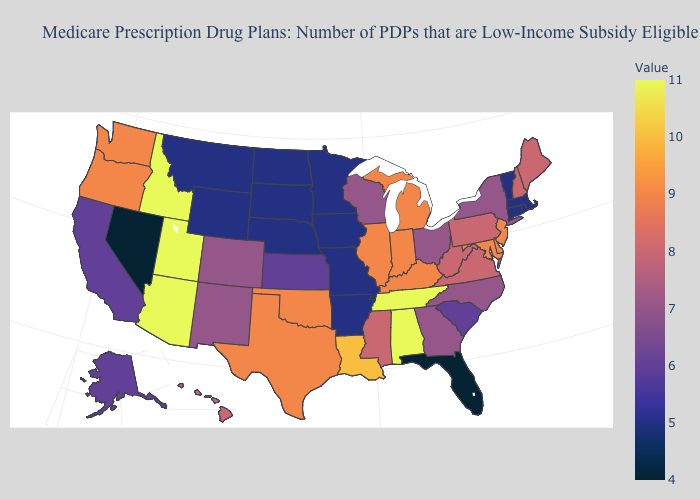Among the states that border Nebraska , does Colorado have the highest value?
Keep it brief. Yes. Does Illinois have the highest value in the MidWest?
Give a very brief answer. Yes. Which states have the lowest value in the USA?
Keep it brief. Florida, Nevada. Does Florida have the lowest value in the USA?
Be succinct. Yes. Among the states that border Connecticut , does Massachusetts have the highest value?
Keep it brief. No. 